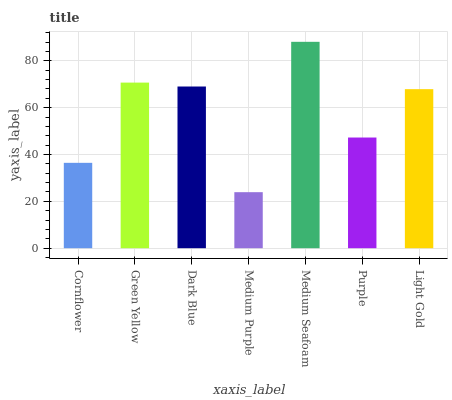Is Medium Purple the minimum?
Answer yes or no. Yes. Is Medium Seafoam the maximum?
Answer yes or no. Yes. Is Green Yellow the minimum?
Answer yes or no. No. Is Green Yellow the maximum?
Answer yes or no. No. Is Green Yellow greater than Cornflower?
Answer yes or no. Yes. Is Cornflower less than Green Yellow?
Answer yes or no. Yes. Is Cornflower greater than Green Yellow?
Answer yes or no. No. Is Green Yellow less than Cornflower?
Answer yes or no. No. Is Light Gold the high median?
Answer yes or no. Yes. Is Light Gold the low median?
Answer yes or no. Yes. Is Dark Blue the high median?
Answer yes or no. No. Is Dark Blue the low median?
Answer yes or no. No. 